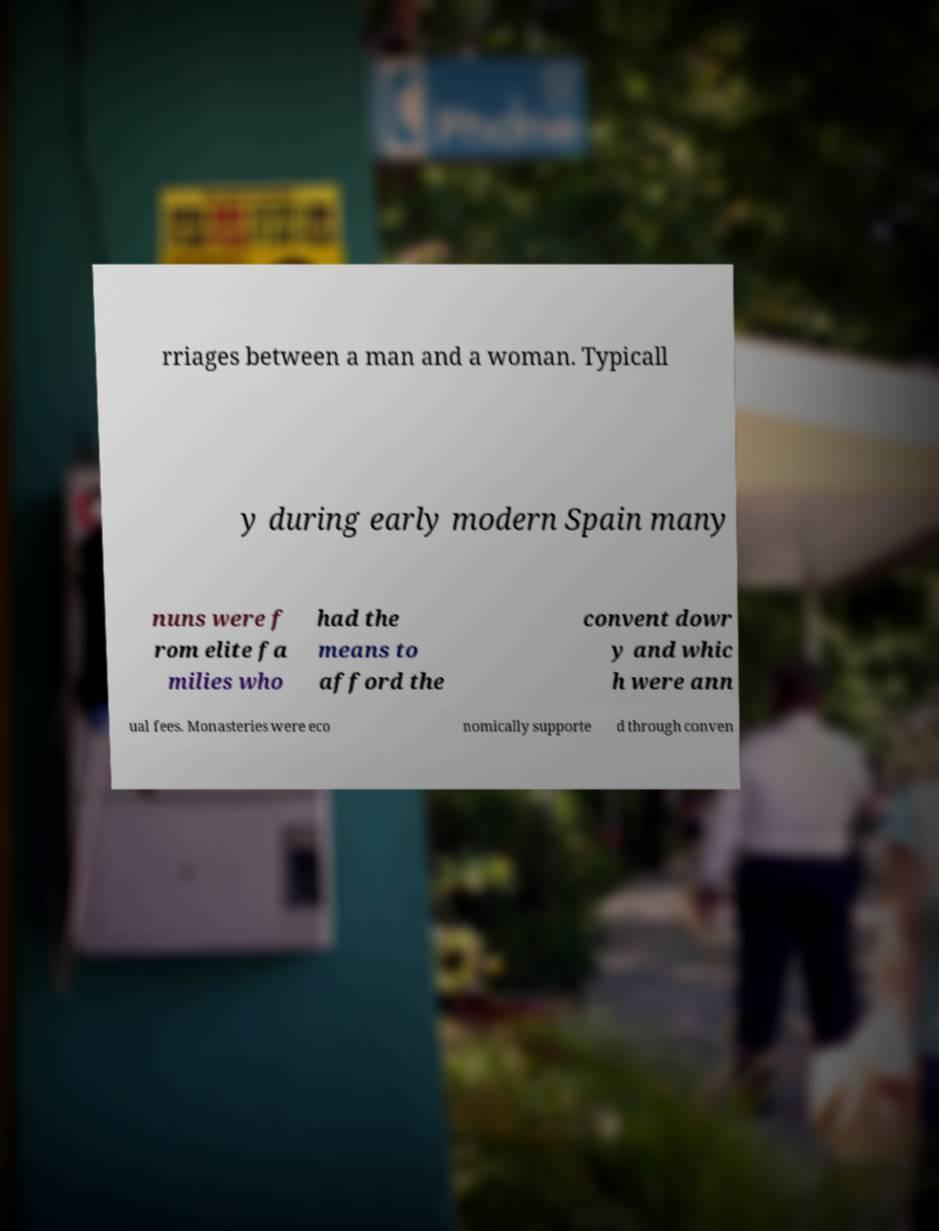Can you read and provide the text displayed in the image?This photo seems to have some interesting text. Can you extract and type it out for me? rriages between a man and a woman. Typicall y during early modern Spain many nuns were f rom elite fa milies who had the means to afford the convent dowr y and whic h were ann ual fees. Monasteries were eco nomically supporte d through conven 